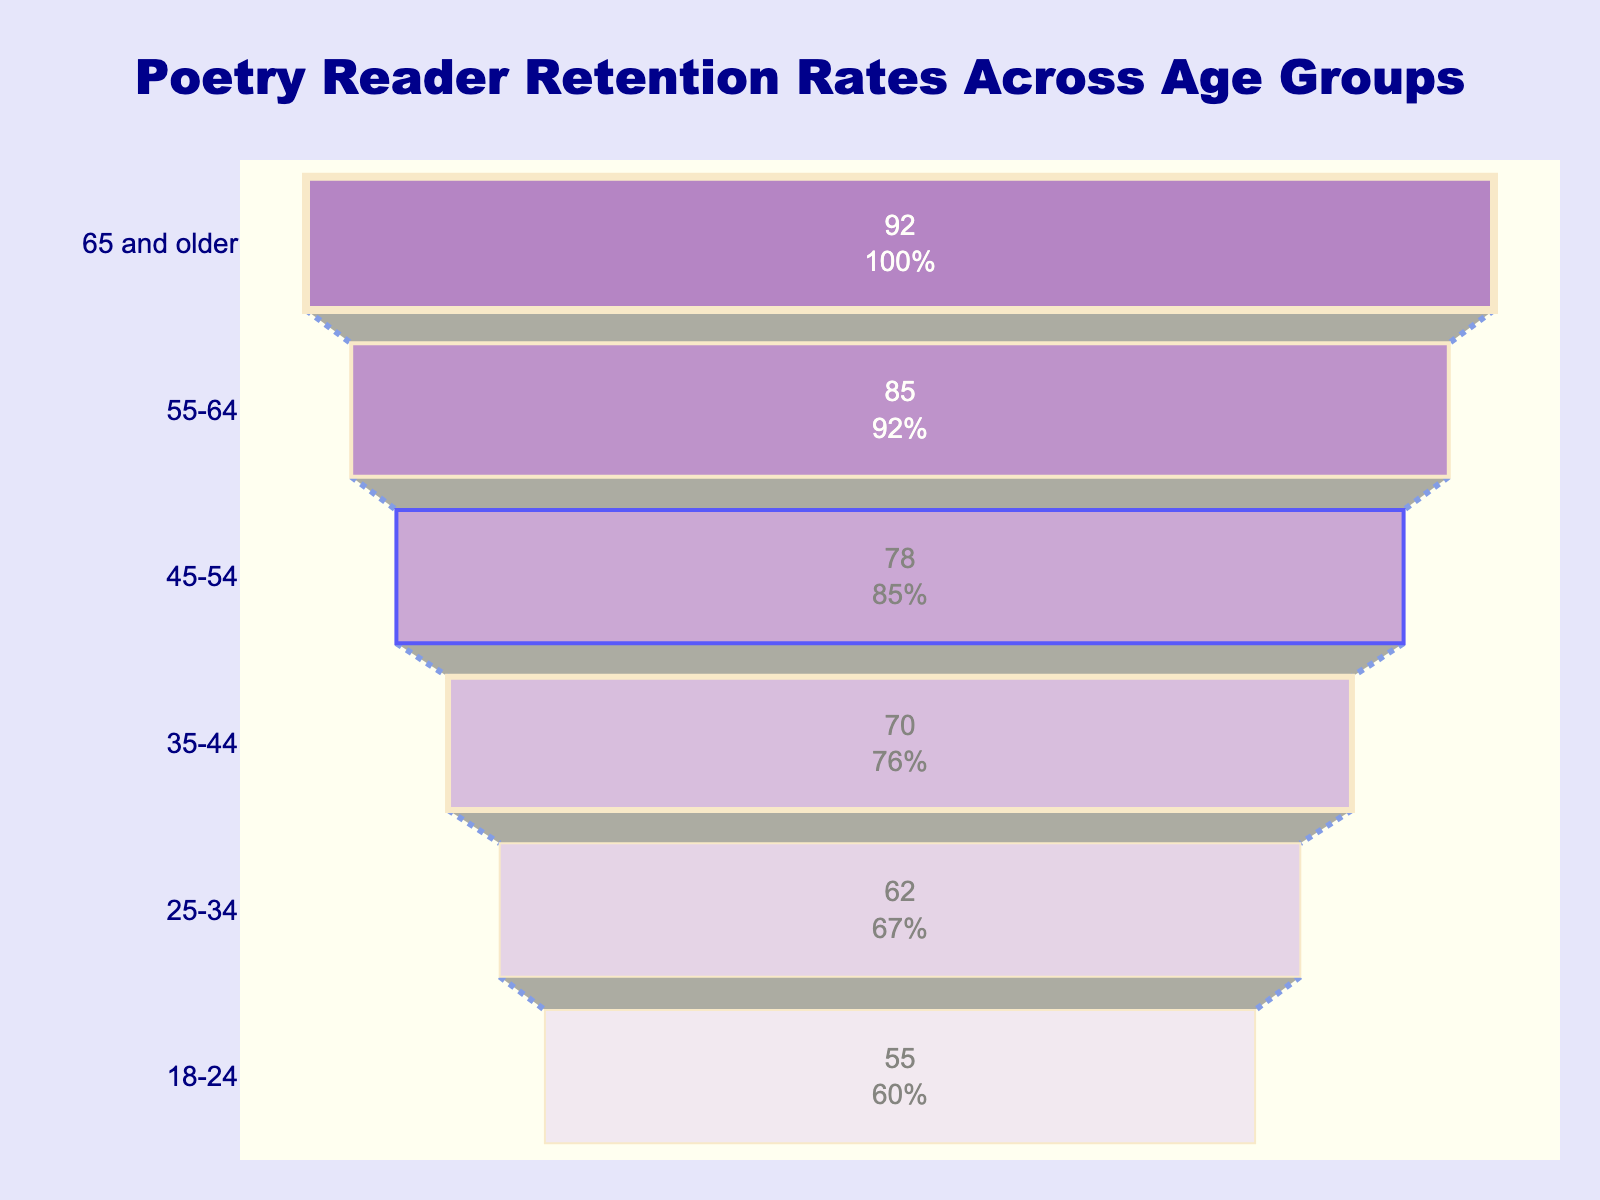What's the title of the chart? The title is located at the top center of the figure. It reads "Poetry Reader Retention Rates Across Age Groups."
Answer: Poetry Reader Retention Rates Across Age Groups Which age group has the highest retention rate? The highest retention rate is shown at the widest part of the funnel. It corresponds to the "65 and older" age group, and the Retention Rate is 92%.
Answer: 65 and older What is the retention rate for the 18-24 age group? The retention rate is listed within the segment corresponding to the "18-24" age group. It shows a value of 55%.
Answer: 55% What is the difference in retention rates between the 35-44 and 45-54 age groups? Find the retention rates of the two mentioned age groups and subtract them: 78% (for 45-54) - 70% (for 35-44) = 8%.
Answer: 8% How many age groups are represented in the chart? Count the number of segments in the funnel, each representing a different age group. There are six segments denoted by their respective age groups.
Answer: 6 Which age group shows the smallest retention rate, and what is it? The smallest retention rate is shown at the narrowest lower part of the funnel, corresponding to the "18-24" age group, with a Retention Rate of 55%.
Answer: 18-24, 55% What is the combined retention rate for the age groups 45-54 and 55-64? Add the retention rates for these two age groups: 78% (for 45-54) + 85% (for 55-64) = 163%.
Answer: 163% Is the retention rate higher for the 25-34 age group or the 35-44 age group? Compare the retention rates of the two age groups: 62% (for 25-34) and 70% (for 35-44). The retention rate for the 35-44 age group is higher.
Answer: 35-44 Which age group has a retention rate of 70%? Locate the segment in the funnel that shows a retention rate of 70%. It corresponds to the "35-44" age group.
Answer: 35-44 How does the trend of retention rates change as age groups increase from 18-24 to 65 and older? Observe the funnel chart to identify the overall direction of the retention rates. The rate increases as the age groups progress from 18-24 to 65 and older, starting at 55% and ending at 92%.
Answer: Retention rates increase with age 